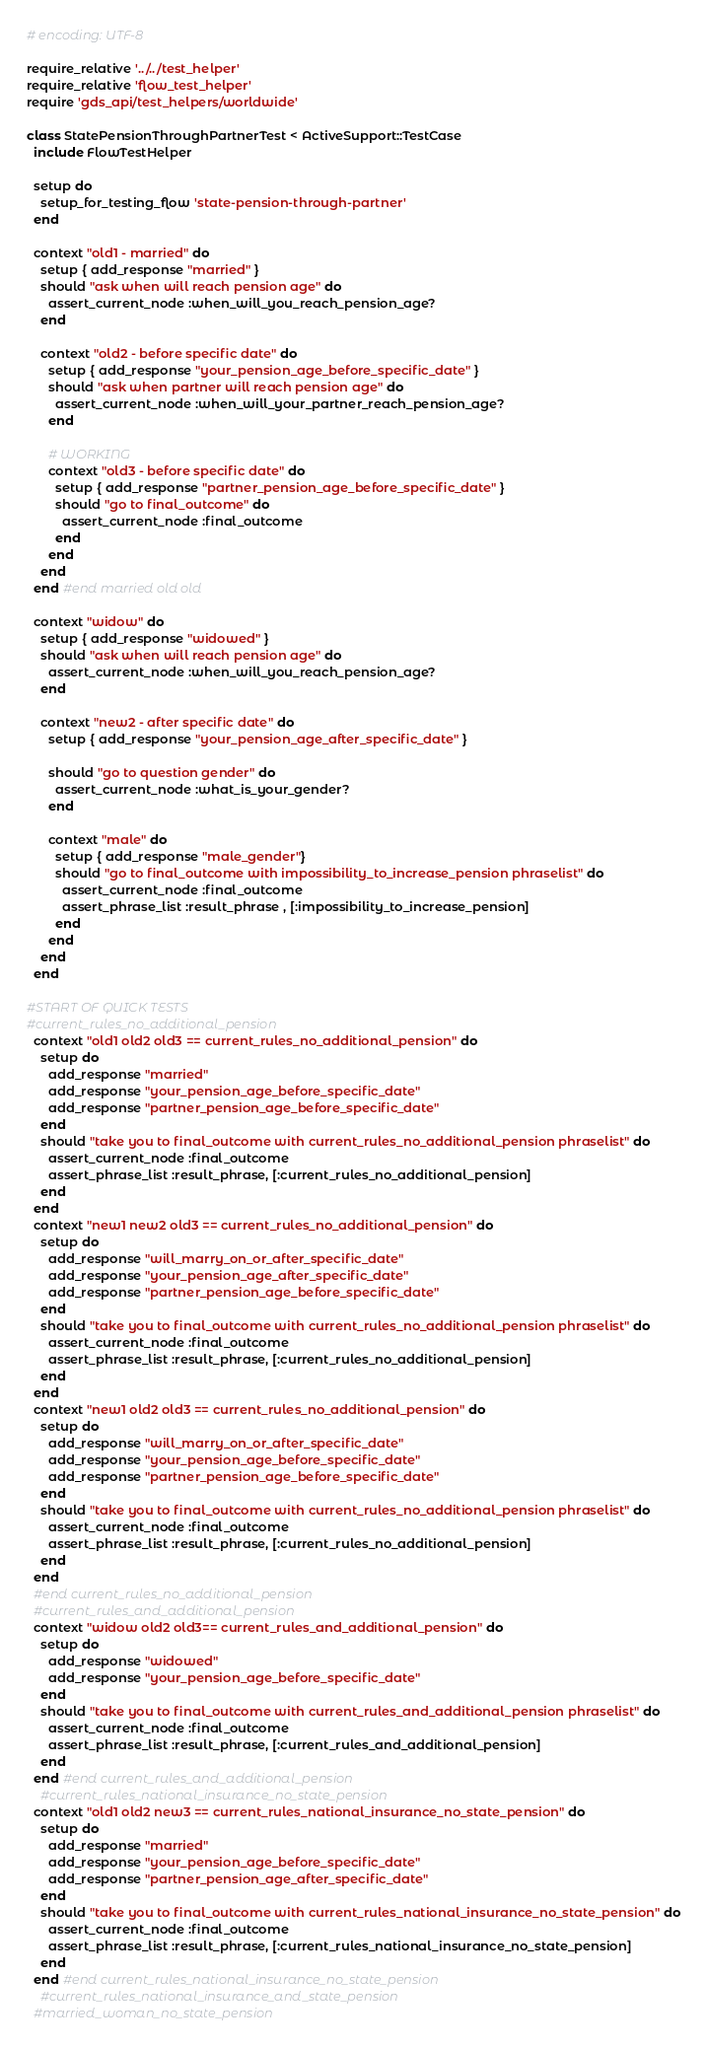<code> <loc_0><loc_0><loc_500><loc_500><_Ruby_># encoding: UTF-8

require_relative '../../test_helper'
require_relative 'flow_test_helper'
require 'gds_api/test_helpers/worldwide'

class StatePensionThroughPartnerTest < ActiveSupport::TestCase
  include FlowTestHelper

  setup do
    setup_for_testing_flow 'state-pension-through-partner'
  end

  context "old1 - married" do
    setup { add_response "married" }
    should "ask when will reach pension age" do
      assert_current_node :when_will_you_reach_pension_age?
    end

    context "old2 - before specific date" do
      setup { add_response "your_pension_age_before_specific_date" }
      should "ask when partner will reach pension age" do
        assert_current_node :when_will_your_partner_reach_pension_age?
      end

      # WORKING 
      context "old3 - before specific date" do
        setup { add_response "partner_pension_age_before_specific_date" }
        should "go to final_outcome" do
          assert_current_node :final_outcome
        end
      end
    end
  end #end married old old
  
  context "widow" do
    setup { add_response "widowed" }
    should "ask when will reach pension age" do
      assert_current_node :when_will_you_reach_pension_age?
    end

    context "new2 - after specific date" do
      setup { add_response "your_pension_age_after_specific_date" }
 
      should "go to question gender" do
        assert_current_node :what_is_your_gender?
      end
      
      context "male" do
        setup { add_response "male_gender"}
        should "go to final_outcome with impossibility_to_increase_pension phraselist" do
          assert_current_node :final_outcome
          assert_phrase_list :result_phrase , [:impossibility_to_increase_pension]
        end
      end
    end
  end
  
#START OF QUICK TESTS  
#current_rules_no_additional_pension
  context "old1 old2 old3 == current_rules_no_additional_pension" do
    setup do
      add_response "married"
      add_response "your_pension_age_before_specific_date"
      add_response "partner_pension_age_before_specific_date"
    end
    should "take you to final_outcome with current_rules_no_additional_pension phraselist" do
      assert_current_node :final_outcome
      assert_phrase_list :result_phrase, [:current_rules_no_additional_pension]
    end
  end 
  context "new1 new2 old3 == current_rules_no_additional_pension" do
    setup do
      add_response "will_marry_on_or_after_specific_date"
      add_response "your_pension_age_after_specific_date"
      add_response "partner_pension_age_before_specific_date"
    end
    should "take you to final_outcome with current_rules_no_additional_pension phraselist" do
      assert_current_node :final_outcome
      assert_phrase_list :result_phrase, [:current_rules_no_additional_pension]
    end
  end
  context "new1 old2 old3 == current_rules_no_additional_pension" do
    setup do
      add_response "will_marry_on_or_after_specific_date"
      add_response "your_pension_age_before_specific_date"
      add_response "partner_pension_age_before_specific_date"
    end
    should "take you to final_outcome with current_rules_no_additional_pension phraselist" do
      assert_current_node :final_outcome
      assert_phrase_list :result_phrase, [:current_rules_no_additional_pension]
    end
  end
  #end current_rules_no_additional_pension
  #current_rules_and_additional_pension
  context "widow old2 old3== current_rules_and_additional_pension" do
    setup do
      add_response "widowed"
      add_response "your_pension_age_before_specific_date"
    end
    should "take you to final_outcome with current_rules_and_additional_pension phraselist" do
      assert_current_node :final_outcome
      assert_phrase_list :result_phrase, [:current_rules_and_additional_pension]
    end
  end #end current_rules_and_additional_pension
    #current_rules_national_insurance_no_state_pension
  context "old1 old2 new3 == current_rules_national_insurance_no_state_pension" do
    setup do
      add_response "married"
      add_response "your_pension_age_before_specific_date"
      add_response "partner_pension_age_after_specific_date"
    end
    should "take you to final_outcome with current_rules_national_insurance_no_state_pension" do
      assert_current_node :final_outcome
      assert_phrase_list :result_phrase, [:current_rules_national_insurance_no_state_pension]
    end
  end #end current_rules_national_insurance_no_state_pension
    #current_rules_national_insurance_and_state_pension
  #married_woman_no_state_pension</code> 